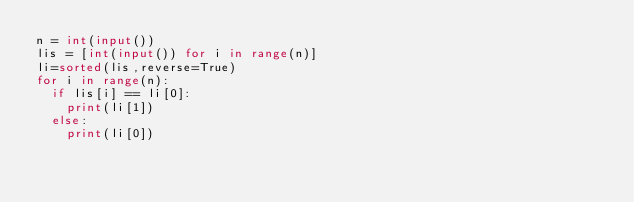Convert code to text. <code><loc_0><loc_0><loc_500><loc_500><_Python_>n = int(input())
lis = [int(input()) for i in range(n)]
li=sorted(lis,reverse=True)
for i in range(n):
  if lis[i] == li[0]:
    print(li[1])
  else:
    print(li[0])
</code> 